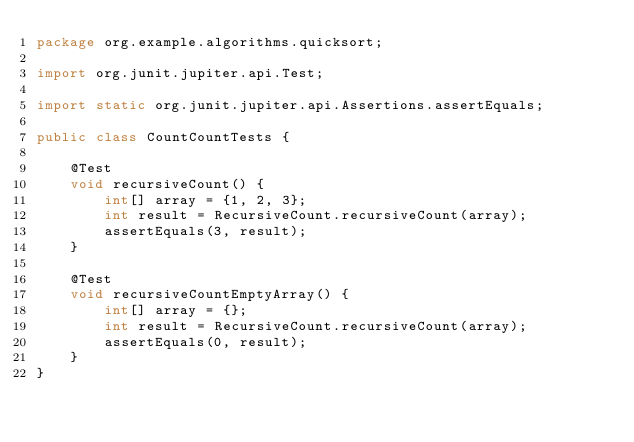<code> <loc_0><loc_0><loc_500><loc_500><_Java_>package org.example.algorithms.quicksort;

import org.junit.jupiter.api.Test;

import static org.junit.jupiter.api.Assertions.assertEquals;

public class CountCountTests {

    @Test
    void recursiveCount() {
        int[] array = {1, 2, 3};
        int result = RecursiveCount.recursiveCount(array);
        assertEquals(3, result);
    }

    @Test
    void recursiveCountEmptyArray() {
        int[] array = {};
        int result = RecursiveCount.recursiveCount(array);
        assertEquals(0, result);
    }
}
</code> 